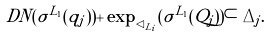Convert formula to latex. <formula><loc_0><loc_0><loc_500><loc_500>\ D N ( \sigma ^ { L _ { 1 } } ( q _ { j } ) ) + \exp _ { \lhd _ { L _ { i } } } ( \sigma ^ { L _ { 1 } } ( Q _ { j } ) ) \subset \Delta _ { j } .</formula> 